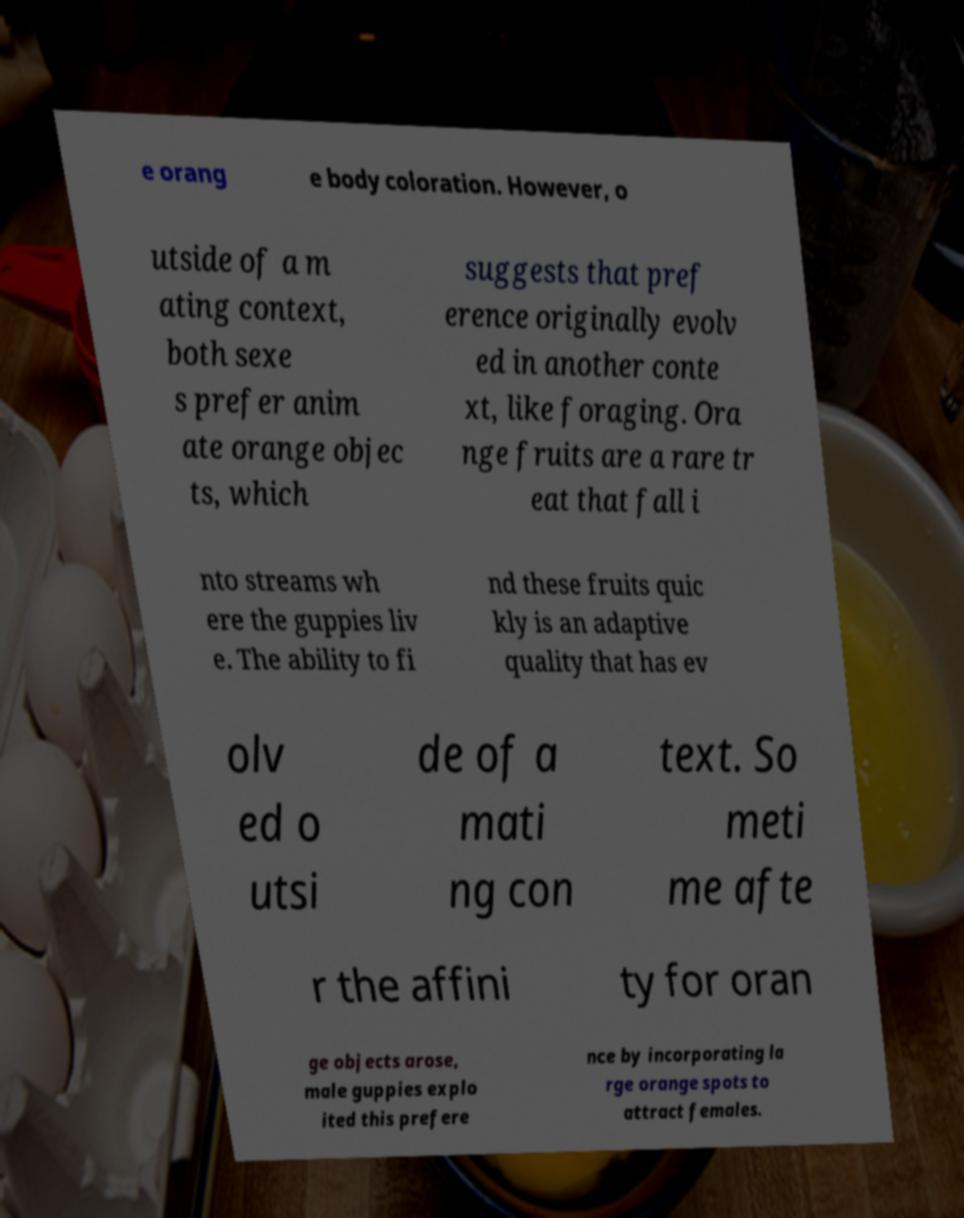Please read and relay the text visible in this image. What does it say? e orang e body coloration. However, o utside of a m ating context, both sexe s prefer anim ate orange objec ts, which suggests that pref erence originally evolv ed in another conte xt, like foraging. Ora nge fruits are a rare tr eat that fall i nto streams wh ere the guppies liv e. The ability to fi nd these fruits quic kly is an adaptive quality that has ev olv ed o utsi de of a mati ng con text. So meti me afte r the affini ty for oran ge objects arose, male guppies explo ited this prefere nce by incorporating la rge orange spots to attract females. 